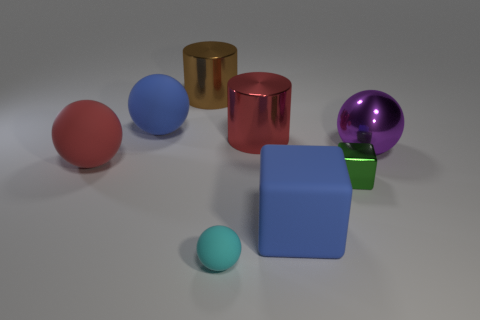What shape is the brown object that is made of the same material as the red cylinder?
Provide a short and direct response. Cylinder. Is there any other thing that is the same shape as the large red metallic thing?
Ensure brevity in your answer.  Yes. There is a tiny cube; how many purple objects are on the left side of it?
Ensure brevity in your answer.  0. Is the number of cyan objects that are on the left side of the big red ball the same as the number of small red blocks?
Make the answer very short. Yes. Are the brown cylinder and the big blue cube made of the same material?
Keep it short and to the point. No. There is a matte thing that is both left of the big red metallic cylinder and in front of the red ball; what is its size?
Offer a very short reply. Small. What number of red shiny things have the same size as the metal block?
Provide a succinct answer. 0. Is the number of big balls the same as the number of large red things?
Offer a terse response. No. There is a ball in front of the big blue object that is in front of the shiny cube; how big is it?
Offer a terse response. Small. There is a thing that is in front of the blue rubber cube; is its shape the same as the blue thing in front of the large shiny sphere?
Provide a short and direct response. No. 